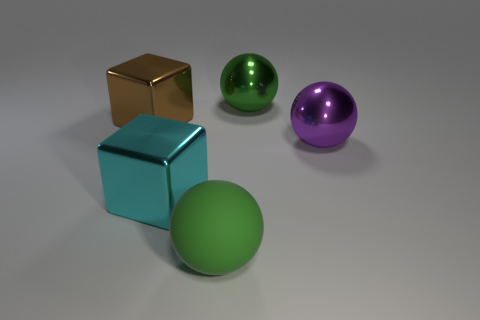There is a large ball on the left side of the metal object behind the brown shiny block; what color is it?
Provide a short and direct response. Green. Are there any spheres that have the same color as the big rubber object?
Offer a very short reply. Yes. What is the shape of the purple metal thing that is the same size as the cyan shiny thing?
Keep it short and to the point. Sphere. There is a metallic object to the left of the cyan cube; what number of things are to the left of it?
Ensure brevity in your answer.  0. How many other things are the same material as the cyan block?
Keep it short and to the point. 3. The large cyan object left of the large shiny sphere behind the brown object is what shape?
Make the answer very short. Cube. What is the size of the green ball that is behind the big purple shiny object?
Provide a short and direct response. Large. Does the purple object have the same material as the cyan block?
Your response must be concise. Yes. What is the shape of the large cyan object that is made of the same material as the big brown block?
Make the answer very short. Cube. Are there any other things of the same color as the matte sphere?
Offer a terse response. Yes. 